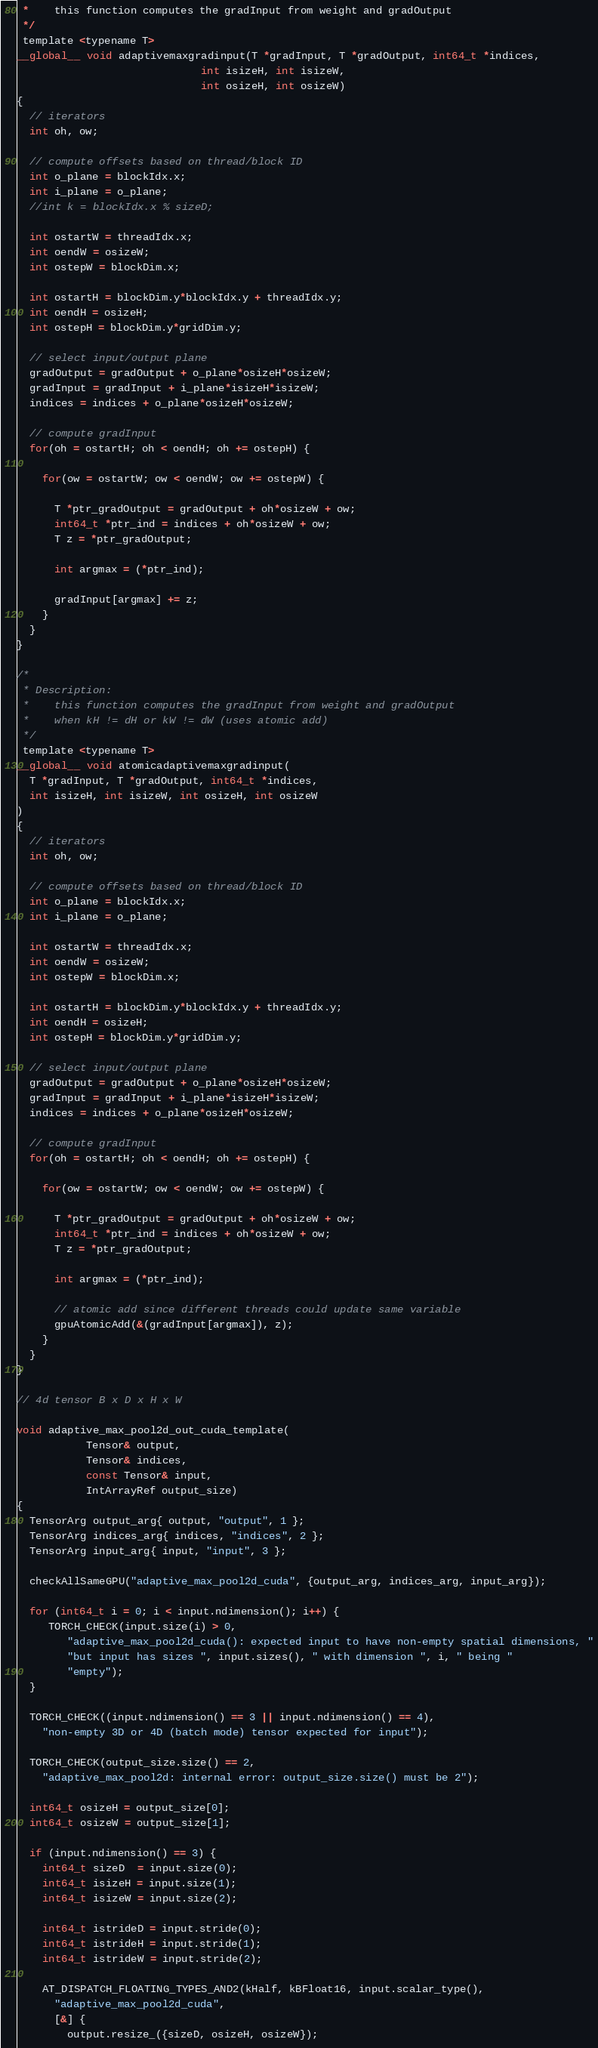<code> <loc_0><loc_0><loc_500><loc_500><_Cuda_> *    this function computes the gradInput from weight and gradOutput
 */
 template <typename T>
__global__ void adaptivemaxgradinput(T *gradInput, T *gradOutput, int64_t *indices,
                             int isizeH, int isizeW,
                             int osizeH, int osizeW)
{
  // iterators
  int oh, ow;

  // compute offsets based on thread/block ID
  int o_plane = blockIdx.x;
  int i_plane = o_plane;
  //int k = blockIdx.x % sizeD;

  int ostartW = threadIdx.x;
  int oendW = osizeW;
  int ostepW = blockDim.x;

  int ostartH = blockDim.y*blockIdx.y + threadIdx.y;
  int oendH = osizeH;
  int ostepH = blockDim.y*gridDim.y;

  // select input/output plane
  gradOutput = gradOutput + o_plane*osizeH*osizeW;
  gradInput = gradInput + i_plane*isizeH*isizeW;
  indices = indices + o_plane*osizeH*osizeW;

  // compute gradInput
  for(oh = ostartH; oh < oendH; oh += ostepH) {

    for(ow = ostartW; ow < oendW; ow += ostepW) {

      T *ptr_gradOutput = gradOutput + oh*osizeW + ow;
      int64_t *ptr_ind = indices + oh*osizeW + ow;
      T z = *ptr_gradOutput;

      int argmax = (*ptr_ind);

      gradInput[argmax] += z;
    }
  }
}

/*
 * Description:
 *    this function computes the gradInput from weight and gradOutput
 *    when kH != dH or kW != dW (uses atomic add)
 */
 template <typename T>
__global__ void atomicadaptivemaxgradinput(
  T *gradInput, T *gradOutput, int64_t *indices,
  int isizeH, int isizeW, int osizeH, int osizeW
)
{
  // iterators
  int oh, ow;

  // compute offsets based on thread/block ID
  int o_plane = blockIdx.x;
  int i_plane = o_plane;

  int ostartW = threadIdx.x;
  int oendW = osizeW;
  int ostepW = blockDim.x;

  int ostartH = blockDim.y*blockIdx.y + threadIdx.y;
  int oendH = osizeH;
  int ostepH = blockDim.y*gridDim.y;

  // select input/output plane
  gradOutput = gradOutput + o_plane*osizeH*osizeW;
  gradInput = gradInput + i_plane*isizeH*isizeW;
  indices = indices + o_plane*osizeH*osizeW;

  // compute gradInput
  for(oh = ostartH; oh < oendH; oh += ostepH) {

    for(ow = ostartW; ow < oendW; ow += ostepW) {

      T *ptr_gradOutput = gradOutput + oh*osizeW + ow;
      int64_t *ptr_ind = indices + oh*osizeW + ow;
      T z = *ptr_gradOutput;

      int argmax = (*ptr_ind);

      // atomic add since different threads could update same variable
      gpuAtomicAdd(&(gradInput[argmax]), z);
    }
  }
}

// 4d tensor B x D x H x W

void adaptive_max_pool2d_out_cuda_template(
           Tensor& output,
           Tensor& indices,
           const Tensor& input,
           IntArrayRef output_size)
{
  TensorArg output_arg{ output, "output", 1 };
  TensorArg indices_arg{ indices, "indices", 2 };
  TensorArg input_arg{ input, "input", 3 };

  checkAllSameGPU("adaptive_max_pool2d_cuda", {output_arg, indices_arg, input_arg});

  for (int64_t i = 0; i < input.ndimension(); i++) {
     TORCH_CHECK(input.size(i) > 0,
        "adaptive_max_pool2d_cuda(): expected input to have non-empty spatial dimensions, "
        "but input has sizes ", input.sizes(), " with dimension ", i, " being "
        "empty");
  }

  TORCH_CHECK((input.ndimension() == 3 || input.ndimension() == 4),
    "non-empty 3D or 4D (batch mode) tensor expected for input");

  TORCH_CHECK(output_size.size() == 2,
    "adaptive_max_pool2d: internal error: output_size.size() must be 2");

  int64_t osizeH = output_size[0];
  int64_t osizeW = output_size[1];

  if (input.ndimension() == 3) {
    int64_t sizeD  = input.size(0);
    int64_t isizeH = input.size(1);
    int64_t isizeW = input.size(2);

    int64_t istrideD = input.stride(0);
    int64_t istrideH = input.stride(1);
    int64_t istrideW = input.stride(2);

    AT_DISPATCH_FLOATING_TYPES_AND2(kHalf, kBFloat16, input.scalar_type(),
      "adaptive_max_pool2d_cuda",
      [&] {
        output.resize_({sizeD, osizeH, osizeW});</code> 